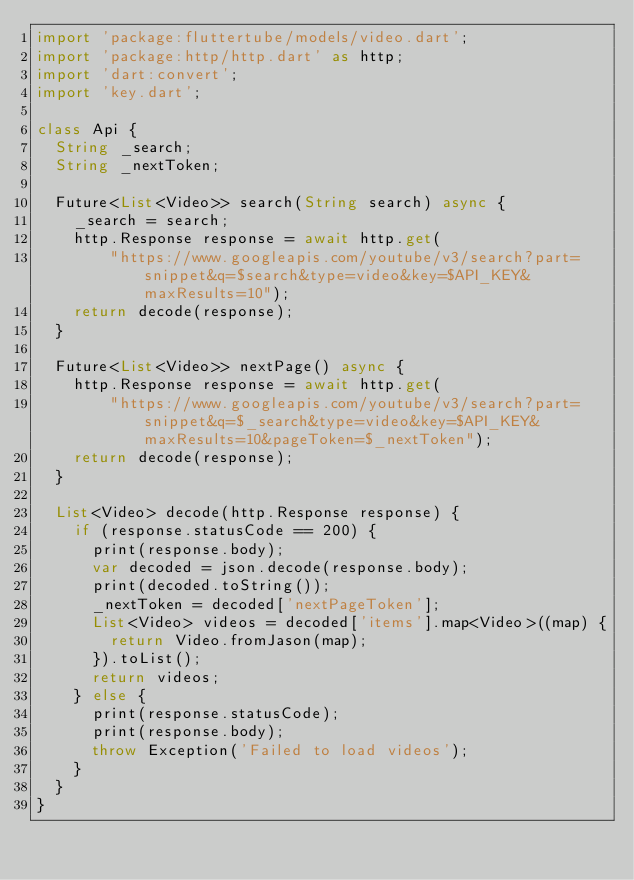Convert code to text. <code><loc_0><loc_0><loc_500><loc_500><_Dart_>import 'package:fluttertube/models/video.dart';
import 'package:http/http.dart' as http;
import 'dart:convert';
import 'key.dart';

class Api {
  String _search;
  String _nextToken;

  Future<List<Video>> search(String search) async {
    _search = search;
    http.Response response = await http.get(
        "https://www.googleapis.com/youtube/v3/search?part=snippet&q=$search&type=video&key=$API_KEY&maxResults=10");
    return decode(response);
  }

  Future<List<Video>> nextPage() async {
    http.Response response = await http.get(
        "https://www.googleapis.com/youtube/v3/search?part=snippet&q=$_search&type=video&key=$API_KEY&maxResults=10&pageToken=$_nextToken");
    return decode(response);
  }

  List<Video> decode(http.Response response) {
    if (response.statusCode == 200) {
      print(response.body);
      var decoded = json.decode(response.body);
      print(decoded.toString());
      _nextToken = decoded['nextPageToken'];
      List<Video> videos = decoded['items'].map<Video>((map) {
        return Video.fromJason(map);
      }).toList();
      return videos;
    } else {
      print(response.statusCode);
      print(response.body);
      throw Exception('Failed to load videos');
    }
  }
}
</code> 